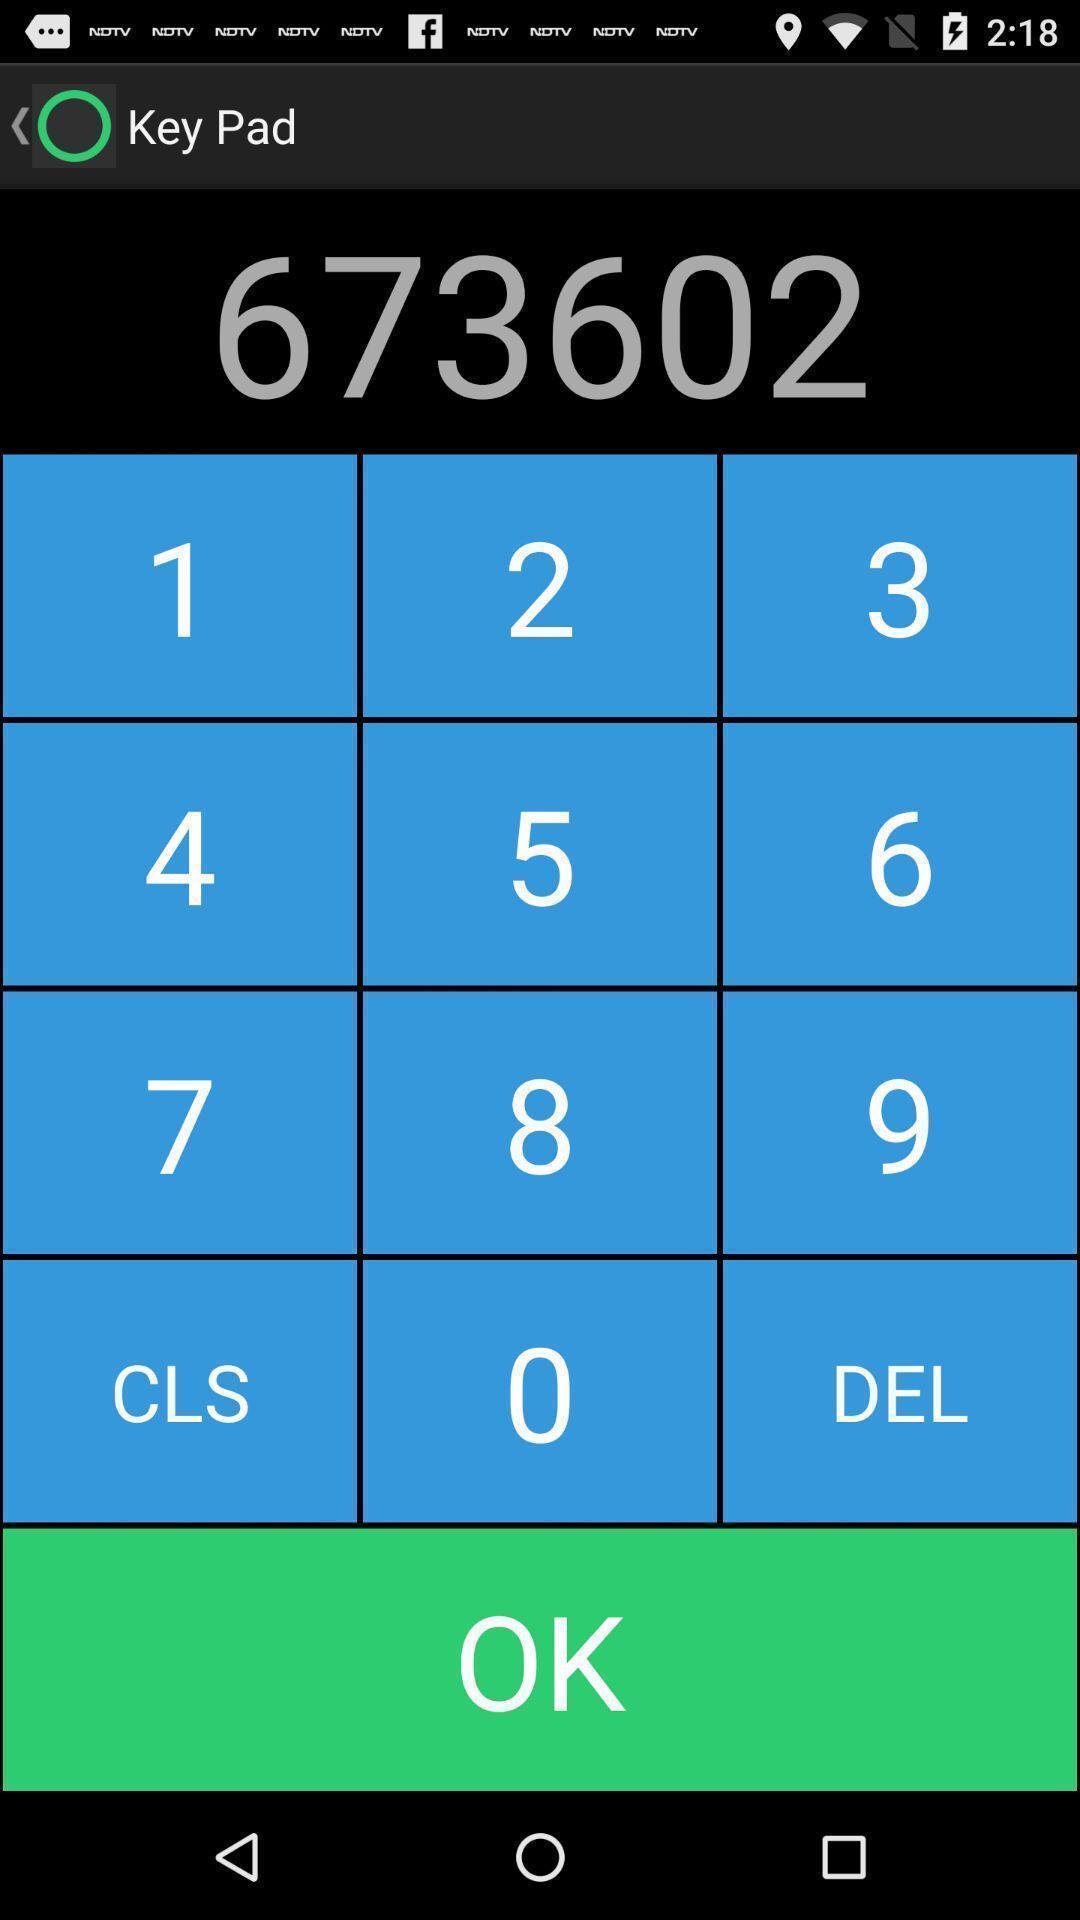Provide a textual representation of this image. Page showing a dial pad. 